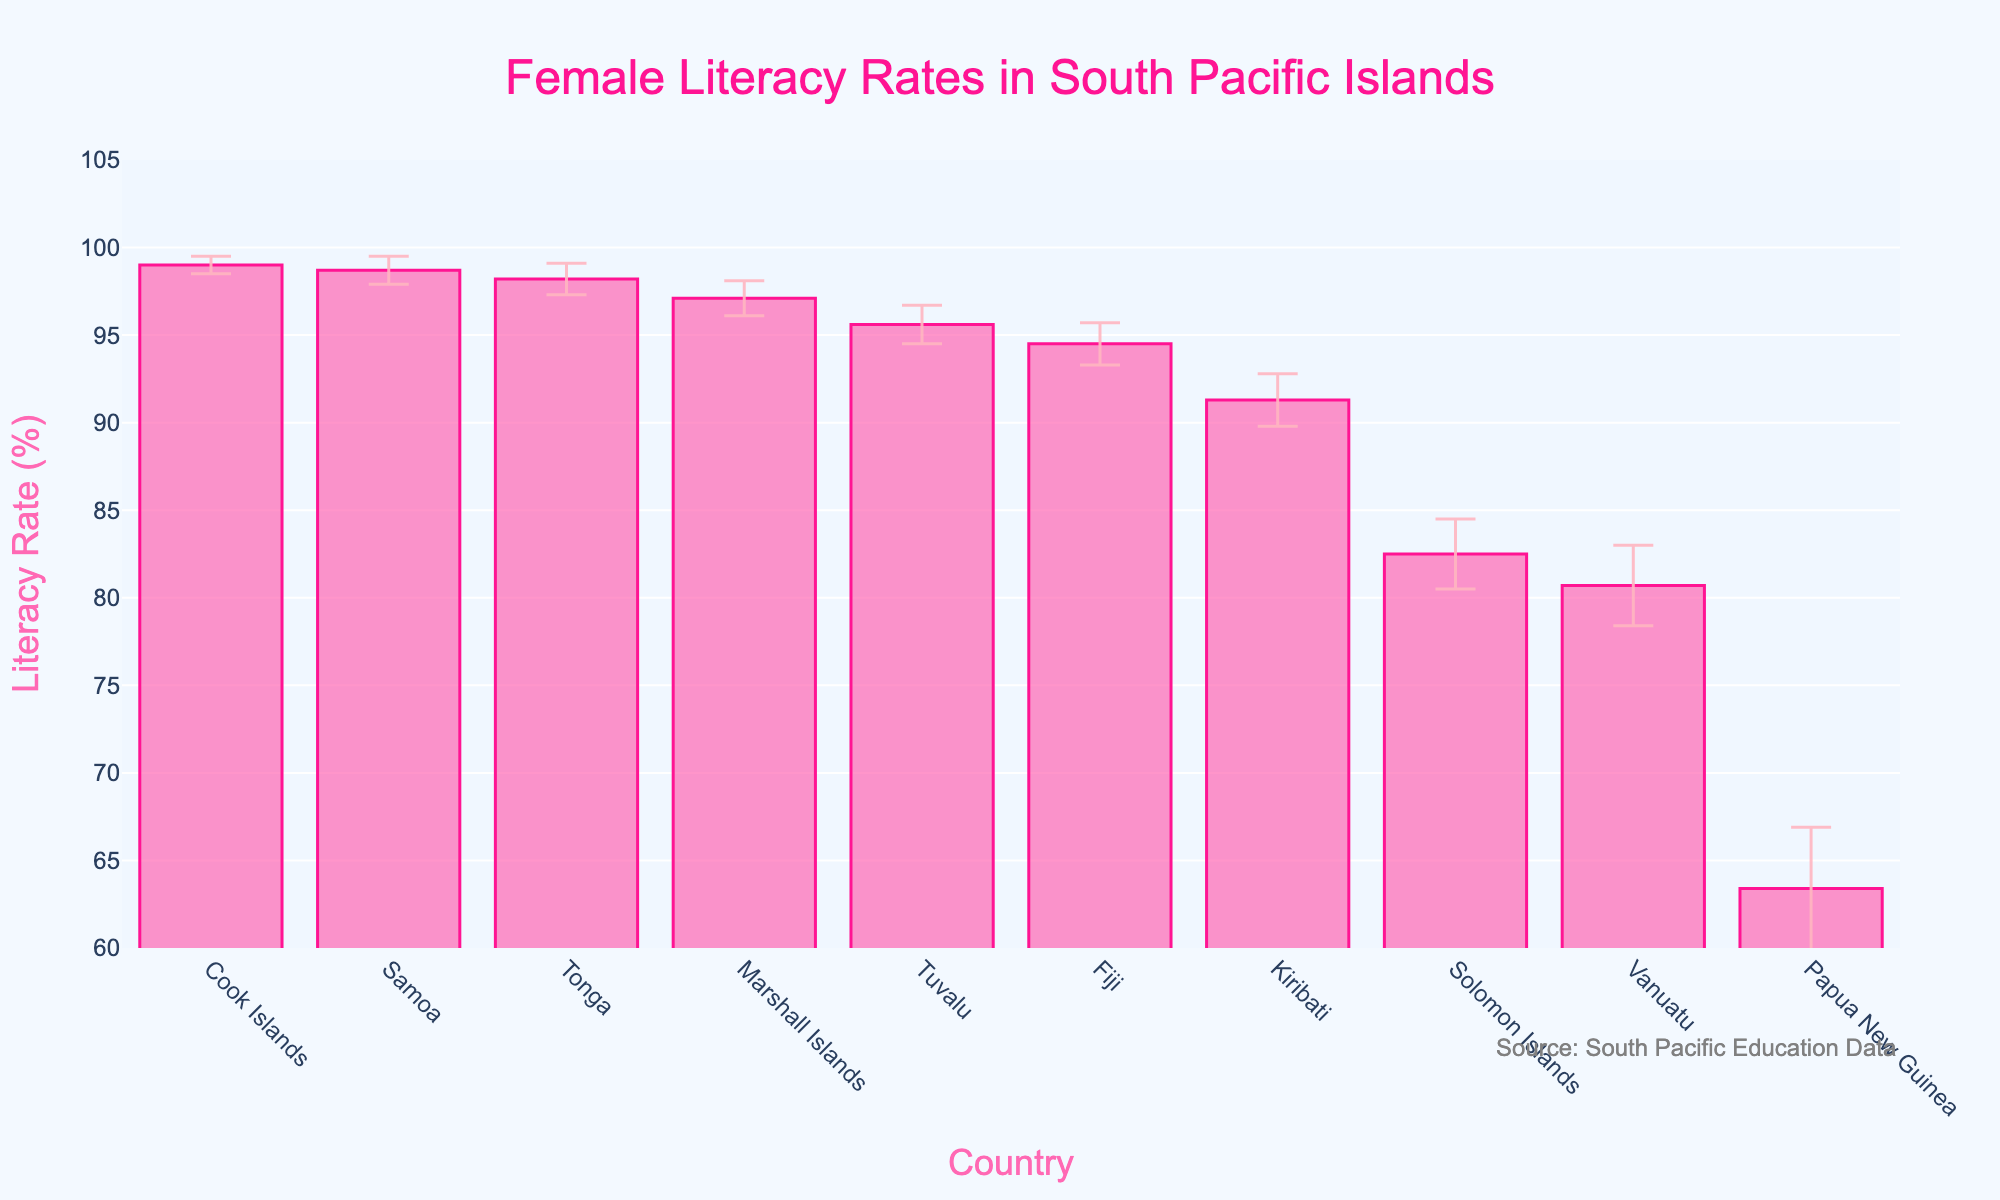what is the title of the plot? The title is located at the top center of the plot. It reads "Female Literacy Rates in South Pacific Islands" as per the standard format observed in the visual.
Answer: Female Literacy Rates in South Pacific Islands Which country has the highest female literacy rate? The country with the highest bar represents the highest female literacy rate. According to the order in the bar chart, Cook Islands holds the highest literacy rate.
Answer: Cook Islands What is the female literacy rate of Vanuatu? Locate the bar labeled "Vanuatu" and check the top of the bar to read the literacy rate value. Vanuatu has a rate of 80.7%.
Answer: 80.7% Which countries have female literacy rates above 95%? Countries with bars above the 95% mark include Cook Islands, Samoa, Tonga, Tuvalu, and Marshall Islands.
Answer: Cook Islands, Samoa, Tonga, Tuvalu, Marshall Islands What is the range of female literacy rates presented in the plot? The range is calculated by subtracting the smallest literacy rate value from the largest. The highest rate is Cook Islands at 99.0%, and the lowest is Papua New Guinea at 63.4%. So, the range is 99.0% - 63.4% = 35.6%.
Answer: 35.6% Which country shows the largest uncertainty in female literacy rate? Assess the error bars' lengths. The country with the widest error bar is Papua New Guinea with a standard deviation of 3.5%.
Answer: Papua New Guinea How much higher is the female literacy rate in Cook Islands compared to Papua New Guinea? Subtract Papua New Guinea's rate from Cook Islands' rate: 99.0% - 63.4% = 35.6%.
Answer: 35.6% How do the literacy rates of Fiji and Tuvalu compare? Fiji has a literacy rate of 94.5%, while Tuvalu has 95.6%. Comparing the two, Tuvalu's literacy rate is slightly higher than Fiji's.
Answer: Tuvalu is higher On average, what is the female literacy rate for the countries listed? Sum all literacy rates and divide by total countries. The sum is 99.0 + 94.5 + 91.3 + 98.7 + 82.5 + 98.2 + 95.6 + 80.7 + 63.4 + 97.1 = 901.00. Divided by 10: 901.00/10 = 90.1%.
Answer: 90.1% Which two countries have the closest female literacy rates? By visually comparing bars' heights, Fiji (94.5%) and Tuvalu (95.6%) have the closest rates, with a difference of only 1.1%.
Answer: Fiji and Tuvalu 